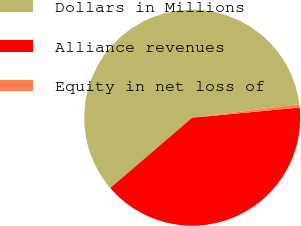Convert chart to OTSL. <chart><loc_0><loc_0><loc_500><loc_500><pie_chart><fcel>Dollars in Millions<fcel>Alliance revenues<fcel>Equity in net loss of<nl><fcel>59.28%<fcel>40.22%<fcel>0.5%<nl></chart> 